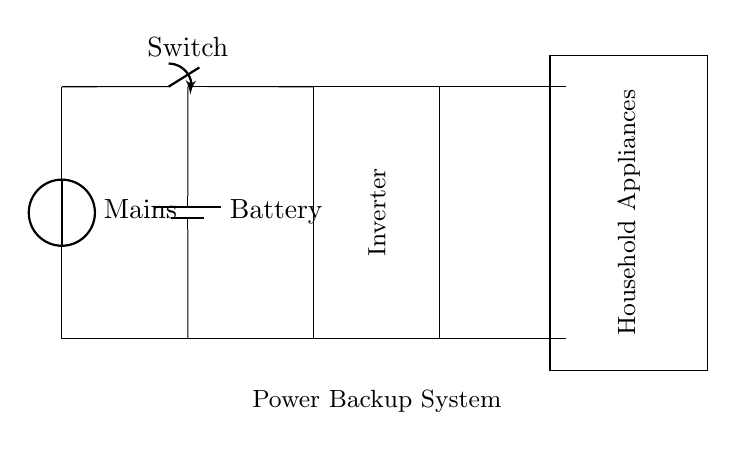What is the main power source in this circuit? The main power source is labeled as "Mains". It provides the initial energy input to the circuit.
Answer: Mains What component is used for energy storage? The component labeled "Battery" is responsible for storing energy in this circuit. It supplies power when the mains are unavailable.
Answer: Battery How does the inverter function in this system? The inverter converts the direct current from the battery into alternating current for use by household appliances. Its role is crucial for making stored energy usable for regular devices.
Answer: Converts DC to AC What is the purpose of the switch in this circuit? The switch, labeled as "Switch", allows the user to control the flow of electricity from the mains to the inverter. This control is important for managing power sources efficiently.
Answer: Control power flow How many main connections are there to household appliances? There are two main connections to household appliances drawn in the diagram: one from the inverter and one from the battery output. This redundancy ensures availability during failures in mains power.
Answer: Two What is the role of the inverter in relation to the battery? The inverter draws energy from the battery to convert it to a usable form (AC) for household appliances, bridging the gap between stored energy and appliance needs during a power outage.
Answer: Provides AC from battery 